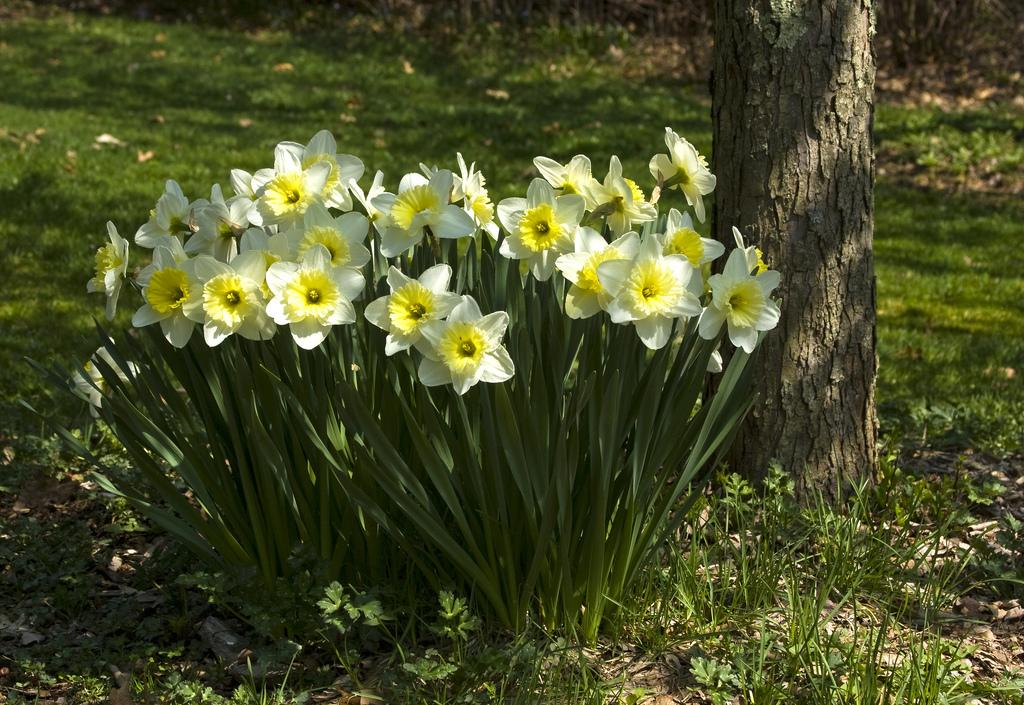What type of flowers can be seen in the image? There are yellow flowers in the image. What else is present on the right side of the image? There is a tree trunk on the right side of the image. What type of vegetation is visible in the image? Grass is visible in the image. How many ducks are sitting on the tree trunk in the image? There are no ducks present in the image; it only features yellow flowers, a tree trunk, and grass. 